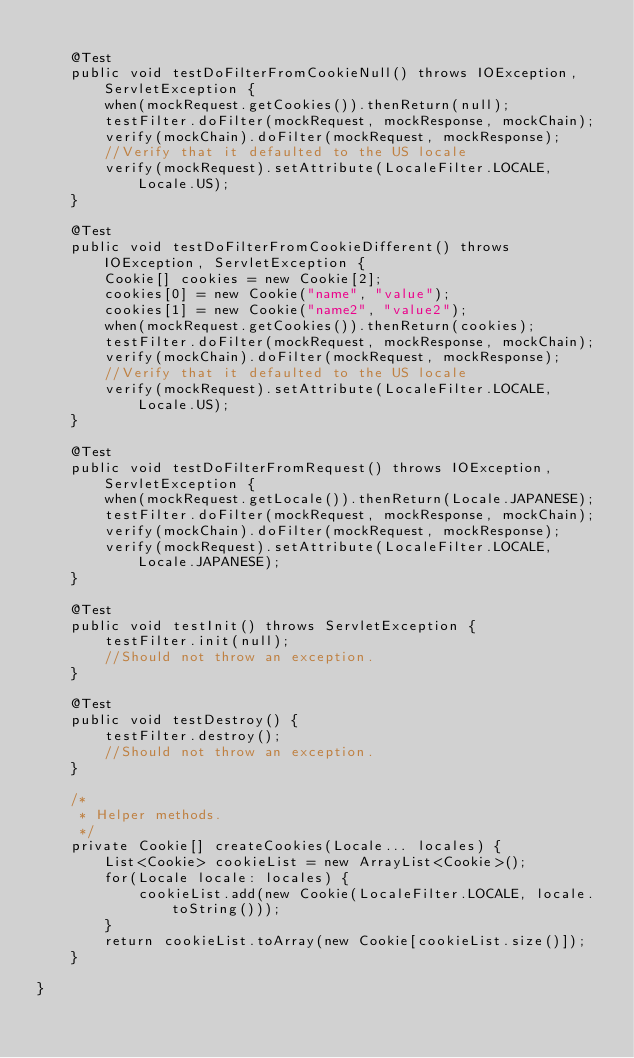Convert code to text. <code><loc_0><loc_0><loc_500><loc_500><_Java_>
    @Test
    public void testDoFilterFromCookieNull() throws IOException, ServletException {
        when(mockRequest.getCookies()).thenReturn(null);
        testFilter.doFilter(mockRequest, mockResponse, mockChain);
        verify(mockChain).doFilter(mockRequest, mockResponse);
        //Verify that it defaulted to the US locale
        verify(mockRequest).setAttribute(LocaleFilter.LOCALE, Locale.US);
    }

    @Test
    public void testDoFilterFromCookieDifferent() throws IOException, ServletException {
        Cookie[] cookies = new Cookie[2];
        cookies[0] = new Cookie("name", "value");
        cookies[1] = new Cookie("name2", "value2");
        when(mockRequest.getCookies()).thenReturn(cookies);
        testFilter.doFilter(mockRequest, mockResponse, mockChain);
        verify(mockChain).doFilter(mockRequest, mockResponse);
        //Verify that it defaulted to the US locale
        verify(mockRequest).setAttribute(LocaleFilter.LOCALE, Locale.US);
    }

    @Test
    public void testDoFilterFromRequest() throws IOException, ServletException {
        when(mockRequest.getLocale()).thenReturn(Locale.JAPANESE);
        testFilter.doFilter(mockRequest, mockResponse, mockChain);
        verify(mockChain).doFilter(mockRequest, mockResponse);
        verify(mockRequest).setAttribute(LocaleFilter.LOCALE, Locale.JAPANESE);
    }

    @Test
    public void testInit() throws ServletException {
        testFilter.init(null);
        //Should not throw an exception.
    }

    @Test
    public void testDestroy() {
        testFilter.destroy();
        //Should not throw an exception.
    }

    /*
     * Helper methods.
     */
    private Cookie[] createCookies(Locale... locales) {
        List<Cookie> cookieList = new ArrayList<Cookie>();
        for(Locale locale: locales) {
            cookieList.add(new Cookie(LocaleFilter.LOCALE, locale.toString()));
        }
        return cookieList.toArray(new Cookie[cookieList.size()]);
    }

}
</code> 